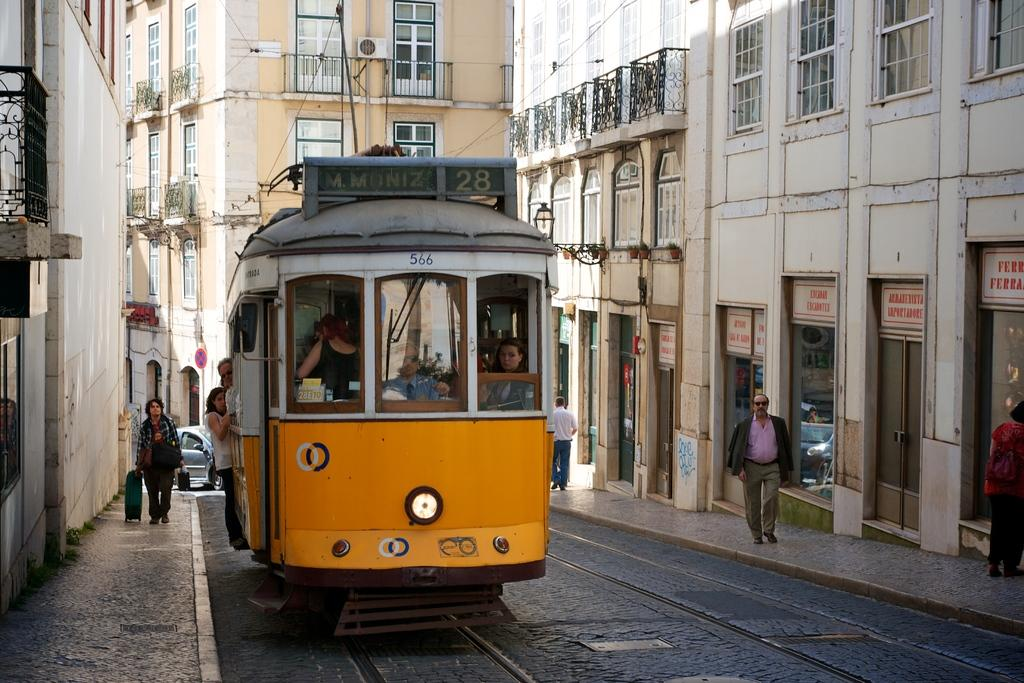What mode of transportation is featured in the image? There is a cable train in the image. Where is the cable train located? The cable train is standing on the road. Who is using the cable train? People are traveling in the cable train. What else can be seen in the image besides the cable train? There are people standing on the footpath and buildings visible in the image. How many apples are being smashed by the net in the image? There are no apples, smashing, or nets present in the image. 